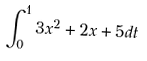Convert formula to latex. <formula><loc_0><loc_0><loc_500><loc_500>\int _ { 0 } ^ { 1 } 3 x ^ { 2 } + 2 x + 5 d t</formula> 